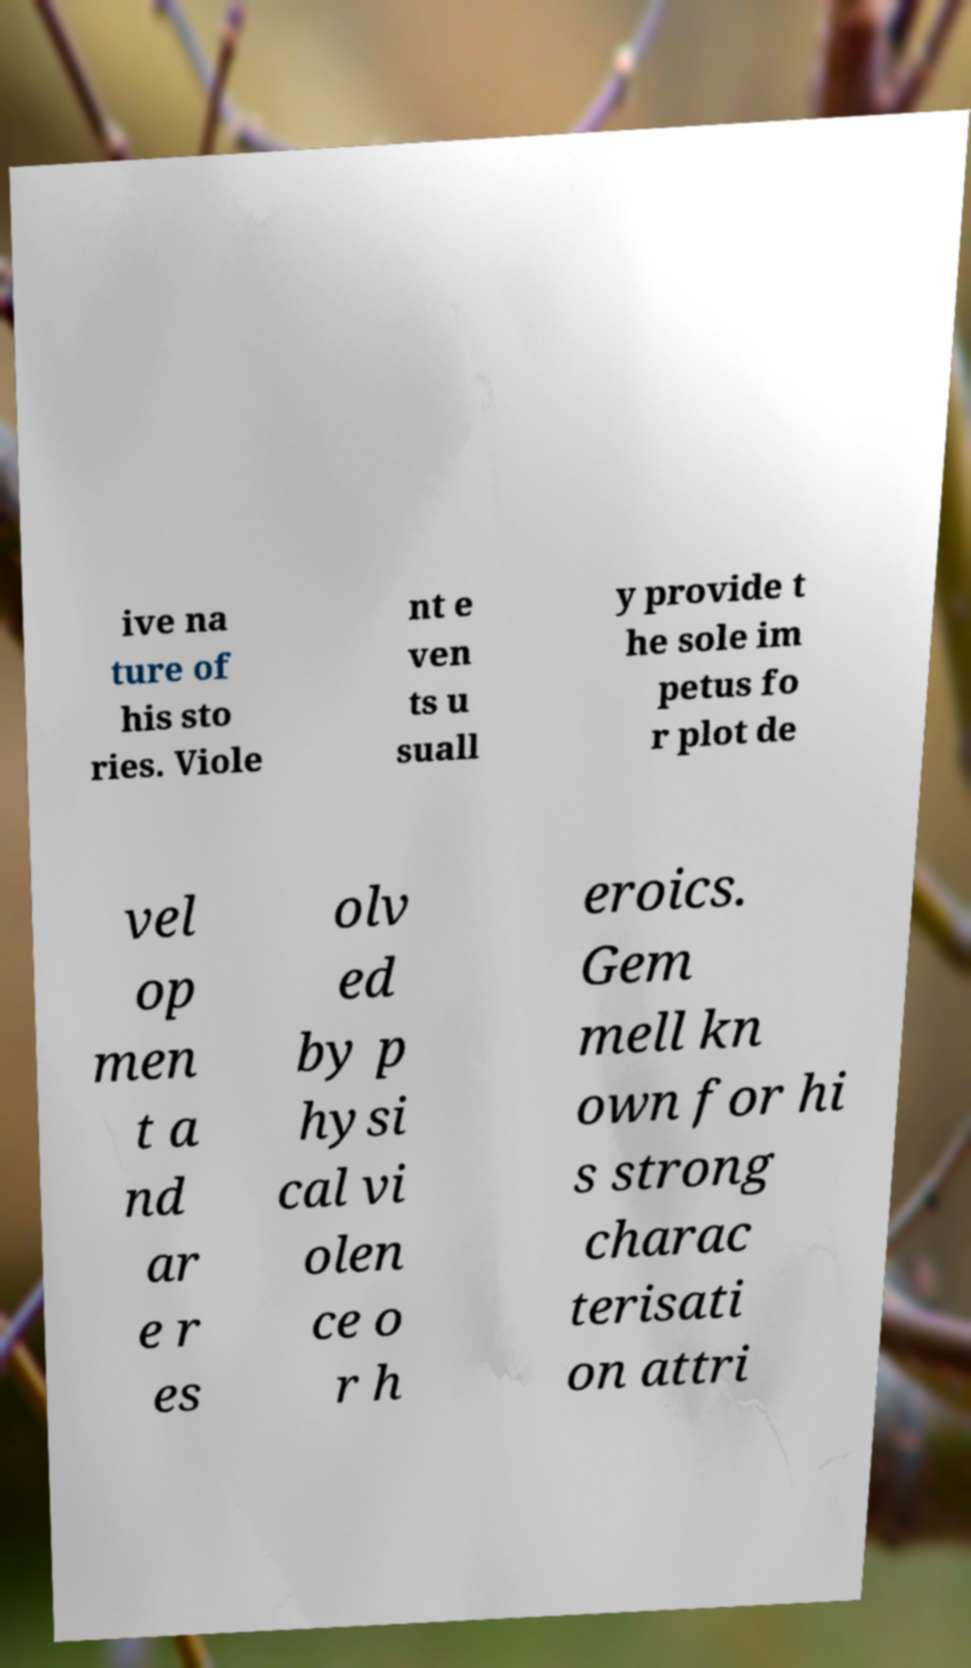Can you read and provide the text displayed in the image?This photo seems to have some interesting text. Can you extract and type it out for me? ive na ture of his sto ries. Viole nt e ven ts u suall y provide t he sole im petus fo r plot de vel op men t a nd ar e r es olv ed by p hysi cal vi olen ce o r h eroics. Gem mell kn own for hi s strong charac terisati on attri 